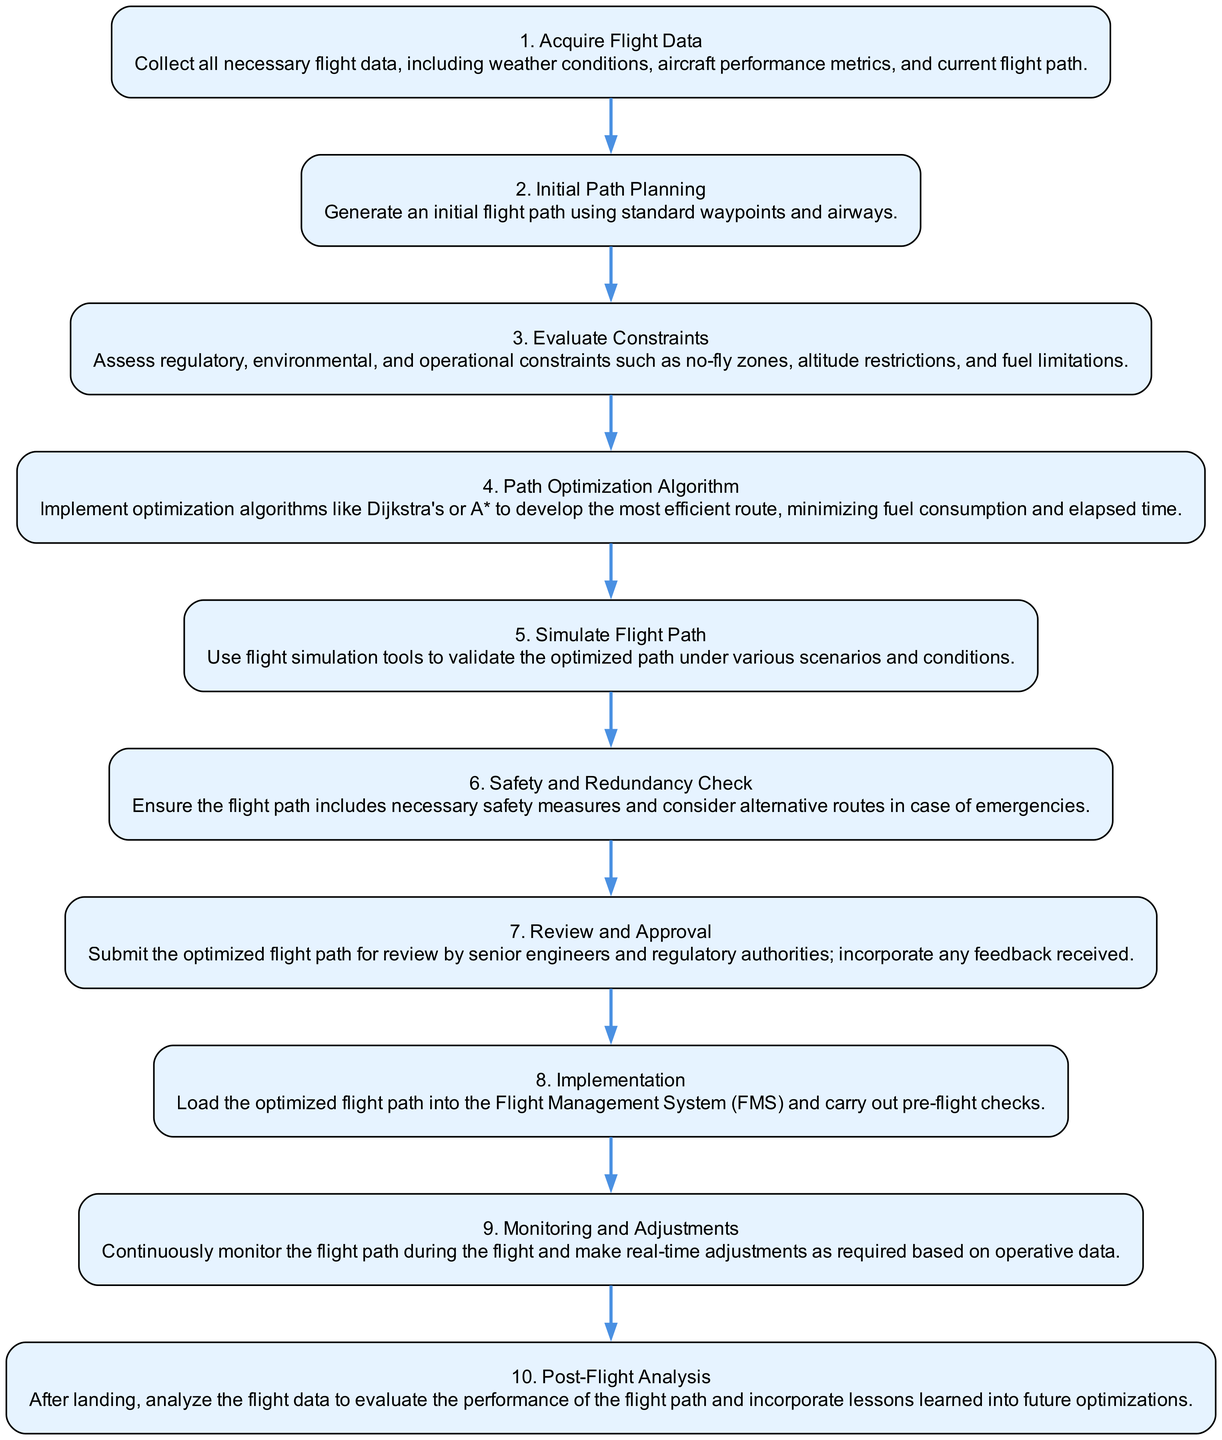What is the first step in the Flight Path Optimization Procedure? The first step is to "Acquire Flight Data," which involves collecting necessary flight data like weather conditions and aircraft performance metrics.
Answer: Acquire Flight Data How many steps are there in total in the procedure? By counting each step in the diagram, we identify a total of ten steps in the Flight Path Optimization Procedure.
Answer: 10 What is the last step in the Flight Path Optimization Procedure? The last step is "Post-Flight Analysis," which involves analyzing flight data after landing to evaluate performance.
Answer: Post-Flight Analysis Which step involves implementing optimization algorithms? The step titled "Path Optimization Algorithm" is where optimization algorithms like Dijkstra's or A* are implemented for route efficiency.
Answer: Path Optimization Algorithm What step follows the "Safety and Redundancy Check"? The next step after "Safety and Redundancy Check" is "Review and Approval." This step involves submitting the optimized flight path for review.
Answer: Review and Approval Identify the step that simulates the flight path under various conditions. The step labeled "Simulate Flight Path" is responsible for using simulation tools to validate the optimized path in different scenarios.
Answer: Simulate Flight Path What type of checks are performed after the implementation of the optimized flight path? Continuous monitoring and adjustments are made during the flight to ensure proper adherence to the optimized path as conditions change.
Answer: Monitoring and Adjustments How does the "Evaluate Constraints" step influence the procedure? This step assesses regulatory and operational constraints which guide the subsequent planning and optimization of the flight path.
Answer: It assesses constraints What is the primary outcome expected from the "Post-Flight Analysis"? The main outcome is to evaluate the performance of the flight path and extract lessons learned for future optimizations.
Answer: Evaluate performance and lessons learned Which step requires senior engineers' approvals? The "Review and Approval" step necessitates review and feedback from senior engineers and regulatory authorities before finalizing the flight path.
Answer: Review and Approval 